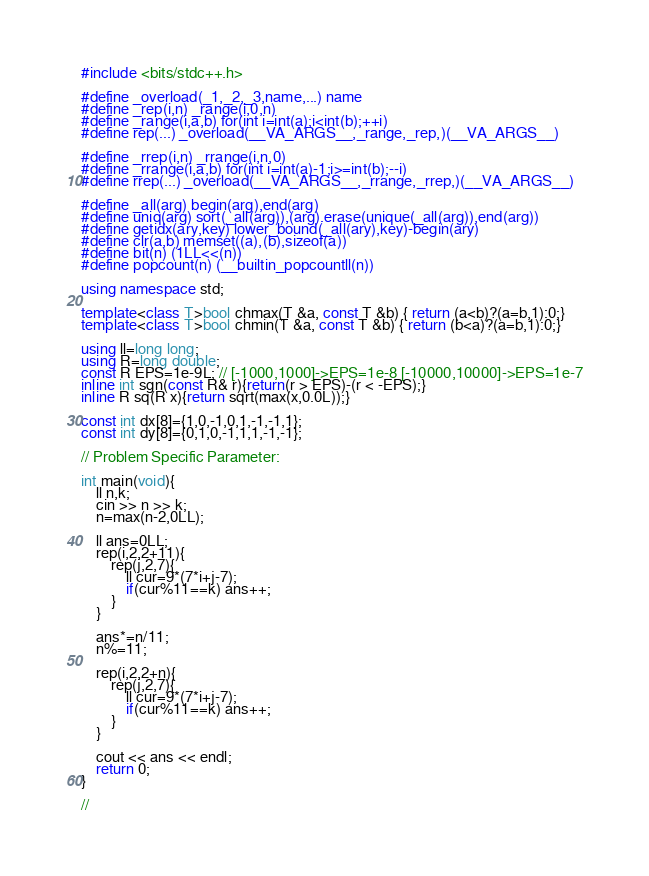<code> <loc_0><loc_0><loc_500><loc_500><_C++_>#include <bits/stdc++.h>

#define _overload(_1,_2,_3,name,...) name
#define _rep(i,n) _range(i,0,n)
#define _range(i,a,b) for(int i=int(a);i<int(b);++i)
#define rep(...) _overload(__VA_ARGS__,_range,_rep,)(__VA_ARGS__)

#define _rrep(i,n) _rrange(i,n,0)
#define _rrange(i,a,b) for(int i=int(a)-1;i>=int(b);--i)
#define rrep(...) _overload(__VA_ARGS__,_rrange,_rrep,)(__VA_ARGS__)

#define _all(arg) begin(arg),end(arg)
#define uniq(arg) sort(_all(arg)),(arg).erase(unique(_all(arg)),end(arg))
#define getidx(ary,key) lower_bound(_all(ary),key)-begin(ary)
#define clr(a,b) memset((a),(b),sizeof(a))
#define bit(n) (1LL<<(n))
#define popcount(n) (__builtin_popcountll(n))

using namespace std;

template<class T>bool chmax(T &a, const T &b) { return (a<b)?(a=b,1):0;}
template<class T>bool chmin(T &a, const T &b) { return (b<a)?(a=b,1):0;}

using ll=long long;
using R=long double;
const R EPS=1e-9L; // [-1000,1000]->EPS=1e-8 [-10000,10000]->EPS=1e-7
inline int sgn(const R& r){return(r > EPS)-(r < -EPS);}
inline R sq(R x){return sqrt(max(x,0.0L));}

const int dx[8]={1,0,-1,0,1,-1,-1,1};
const int dy[8]={0,1,0,-1,1,1,-1,-1};

// Problem Specific Parameter:

int main(void){
	ll n,k;
	cin >> n >> k;
	n=max(n-2,0LL);

	ll ans=0LL;
	rep(i,2,2+11){
		rep(j,2,7){
			ll cur=9*(7*i+j-7);
			if(cur%11==k) ans++;
		}
	}

	ans*=n/11;
	n%=11;

	rep(i,2,2+n){
		rep(j,2,7){
			ll cur=9*(7*i+j-7);
			if(cur%11==k) ans++;
		}
	}

	cout << ans << endl;
	return 0;
}

// </code> 